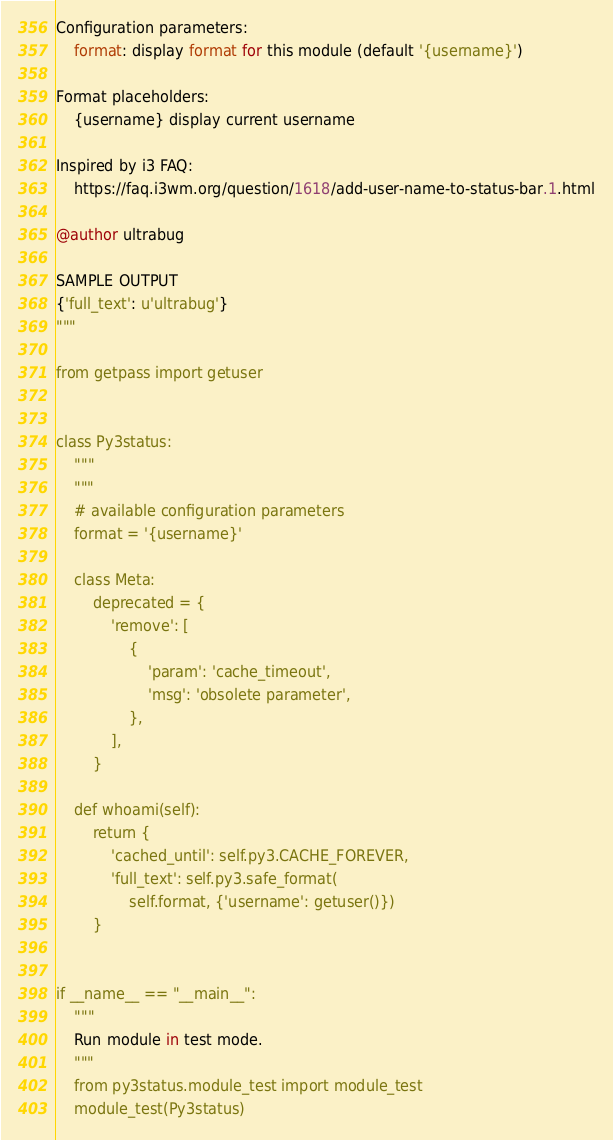Convert code to text. <code><loc_0><loc_0><loc_500><loc_500><_Python_>Configuration parameters:
    format: display format for this module (default '{username}')

Format placeholders:
    {username} display current username

Inspired by i3 FAQ:
    https://faq.i3wm.org/question/1618/add-user-name-to-status-bar.1.html

@author ultrabug

SAMPLE OUTPUT
{'full_text': u'ultrabug'}
"""

from getpass import getuser


class Py3status:
    """
    """
    # available configuration parameters
    format = '{username}'

    class Meta:
        deprecated = {
            'remove': [
                {
                    'param': 'cache_timeout',
                    'msg': 'obsolete parameter',
                },
            ],
        }

    def whoami(self):
        return {
            'cached_until': self.py3.CACHE_FOREVER,
            'full_text': self.py3.safe_format(
                self.format, {'username': getuser()})
        }


if __name__ == "__main__":
    """
    Run module in test mode.
    """
    from py3status.module_test import module_test
    module_test(Py3status)
</code> 